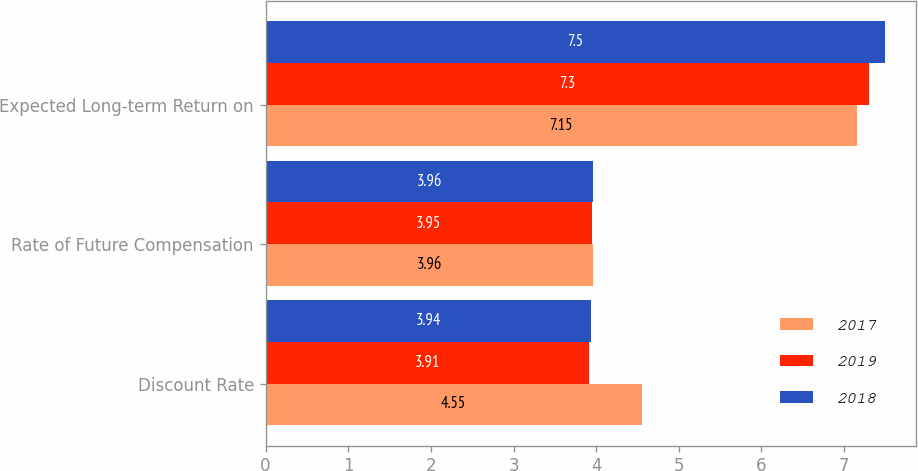Convert chart to OTSL. <chart><loc_0><loc_0><loc_500><loc_500><stacked_bar_chart><ecel><fcel>Discount Rate<fcel>Rate of Future Compensation<fcel>Expected Long-term Return on<nl><fcel>2017<fcel>4.55<fcel>3.96<fcel>7.15<nl><fcel>2019<fcel>3.91<fcel>3.95<fcel>7.3<nl><fcel>2018<fcel>3.94<fcel>3.96<fcel>7.5<nl></chart> 